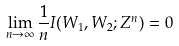<formula> <loc_0><loc_0><loc_500><loc_500>\lim _ { n \rightarrow \infty } \frac { 1 } { n } I ( W _ { 1 } , W _ { 2 } ; Z ^ { n } ) = 0</formula> 